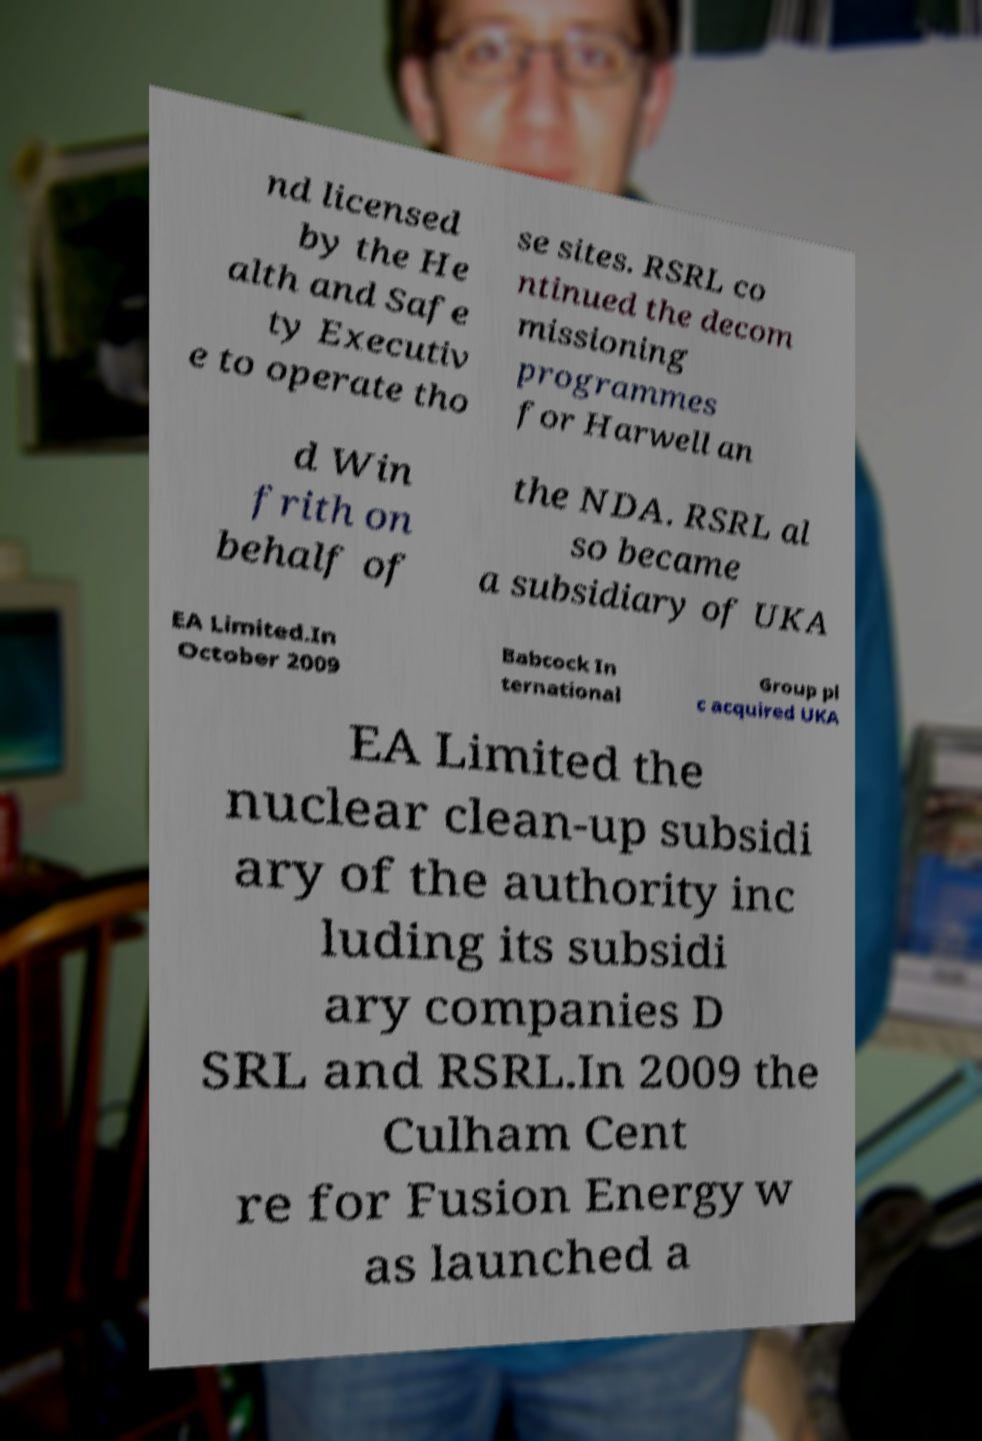Please identify and transcribe the text found in this image. nd licensed by the He alth and Safe ty Executiv e to operate tho se sites. RSRL co ntinued the decom missioning programmes for Harwell an d Win frith on behalf of the NDA. RSRL al so became a subsidiary of UKA EA Limited.In October 2009 Babcock In ternational Group pl c acquired UKA EA Limited the nuclear clean-up subsidi ary of the authority inc luding its subsidi ary companies D SRL and RSRL.In 2009 the Culham Cent re for Fusion Energy w as launched a 